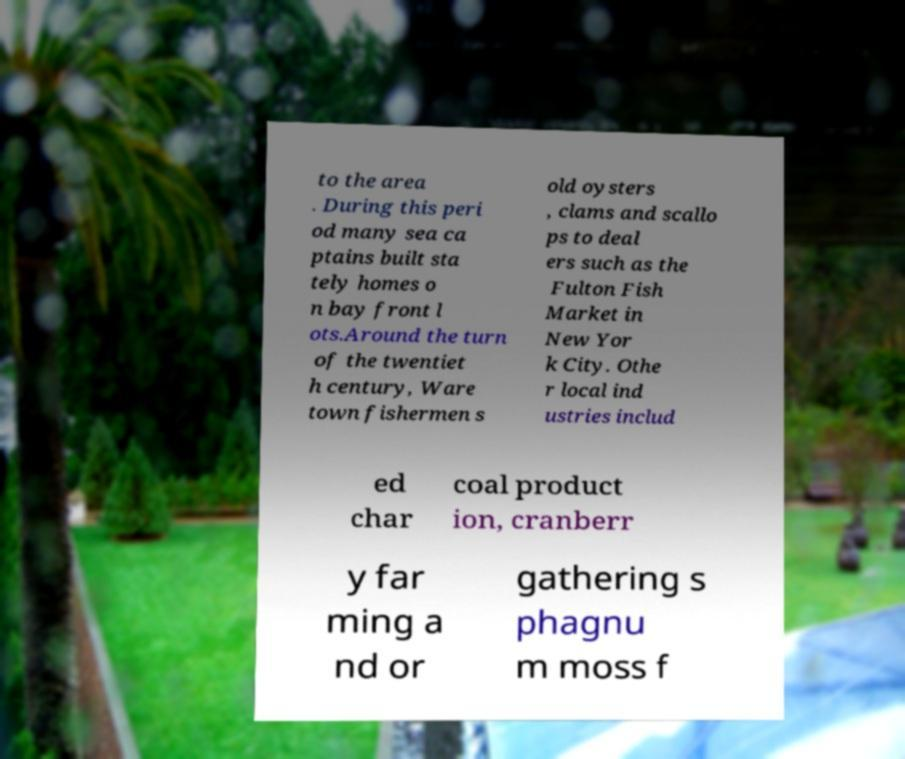Can you accurately transcribe the text from the provided image for me? to the area . During this peri od many sea ca ptains built sta tely homes o n bay front l ots.Around the turn of the twentiet h century, Ware town fishermen s old oysters , clams and scallo ps to deal ers such as the Fulton Fish Market in New Yor k City. Othe r local ind ustries includ ed char coal product ion, cranberr y far ming a nd or gathering s phagnu m moss f 